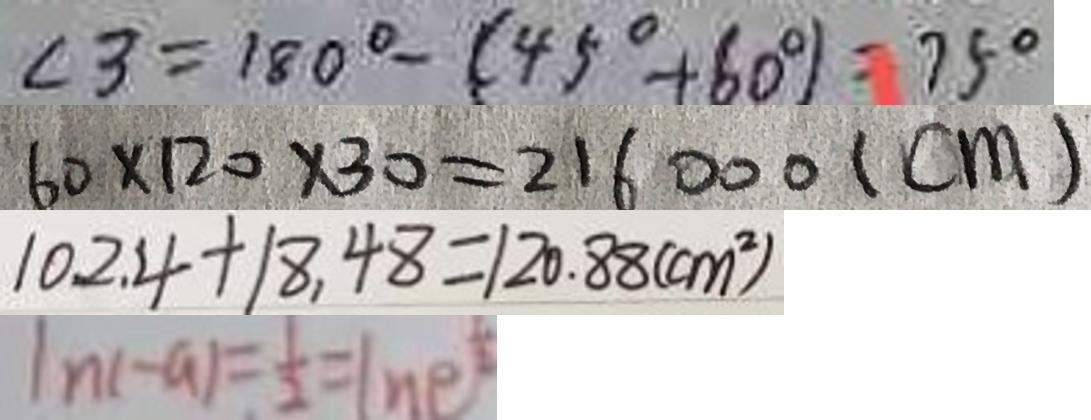Convert formula to latex. <formula><loc_0><loc_0><loc_500><loc_500>\angle 3 = 1 8 0 ^ { \circ } - ( 4 5 ^ { \circ } + 6 0 ^ { \circ } ) = 7 5 ^ { \circ } 
 6 0 \times 1 2 0 \times 3 0 = 2 1 6 0 0 0 ( c m ) 
 1 0 2 . 4 + 1 8 . 4 8 = 1 2 0 . 8 8 ( c m ^ { 2 } ) 
 \vert n ( - a ) = \frac { 1 } { 2 } = ( n e )</formula> 